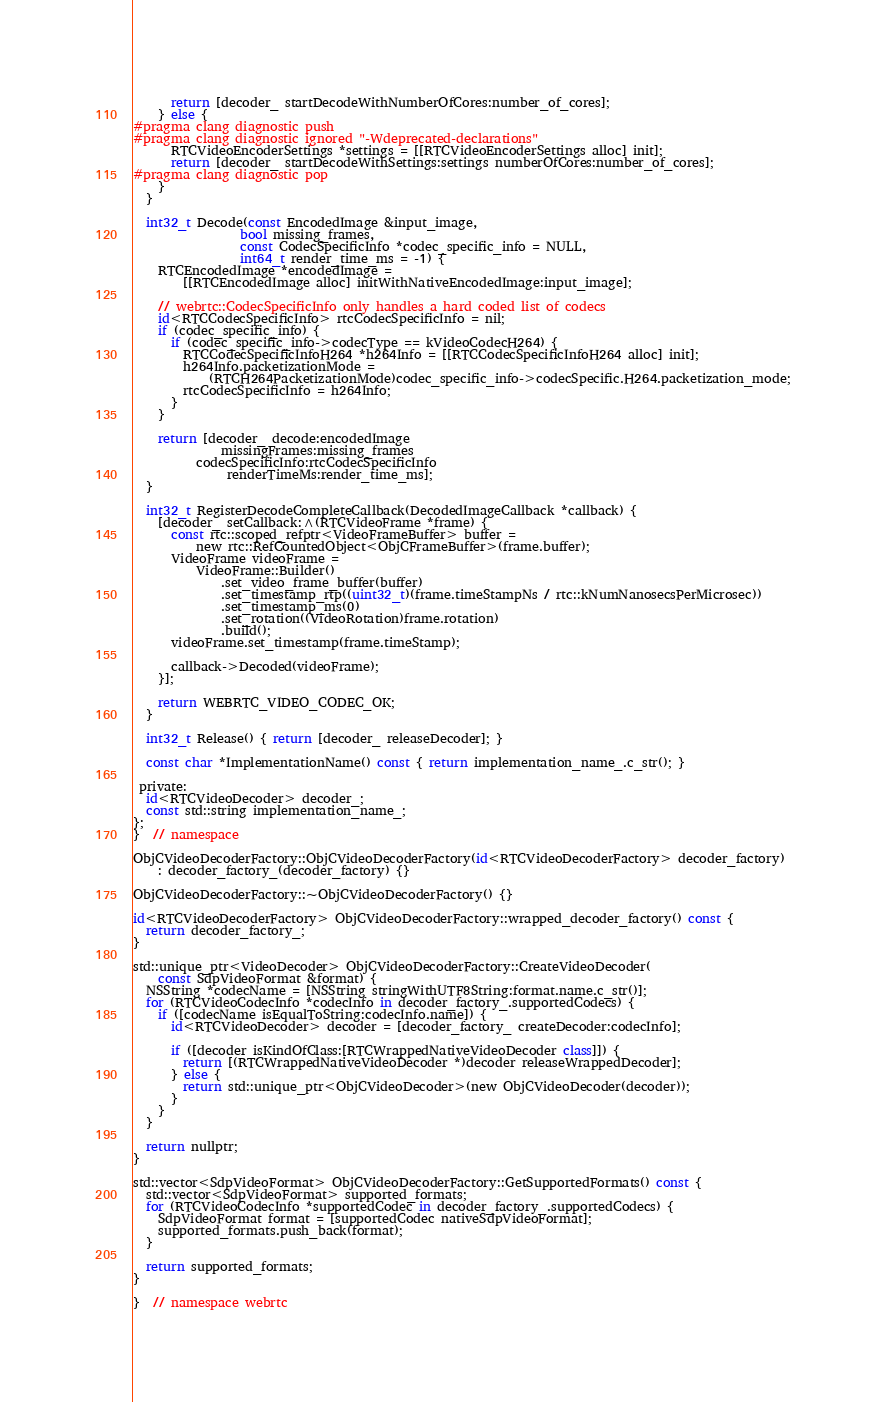<code> <loc_0><loc_0><loc_500><loc_500><_ObjectiveC_>      return [decoder_ startDecodeWithNumberOfCores:number_of_cores];
    } else {
#pragma clang diagnostic push
#pragma clang diagnostic ignored "-Wdeprecated-declarations"
      RTCVideoEncoderSettings *settings = [[RTCVideoEncoderSettings alloc] init];
      return [decoder_ startDecodeWithSettings:settings numberOfCores:number_of_cores];
#pragma clang diagnostic pop
    }
  }

  int32_t Decode(const EncodedImage &input_image,
                 bool missing_frames,
                 const CodecSpecificInfo *codec_specific_info = NULL,
                 int64_t render_time_ms = -1) {
    RTCEncodedImage *encodedImage =
        [[RTCEncodedImage alloc] initWithNativeEncodedImage:input_image];

    // webrtc::CodecSpecificInfo only handles a hard coded list of codecs
    id<RTCCodecSpecificInfo> rtcCodecSpecificInfo = nil;
    if (codec_specific_info) {
      if (codec_specific_info->codecType == kVideoCodecH264) {
        RTCCodecSpecificInfoH264 *h264Info = [[RTCCodecSpecificInfoH264 alloc] init];
        h264Info.packetizationMode =
            (RTCH264PacketizationMode)codec_specific_info->codecSpecific.H264.packetization_mode;
        rtcCodecSpecificInfo = h264Info;
      }
    }

    return [decoder_ decode:encodedImage
              missingFrames:missing_frames
          codecSpecificInfo:rtcCodecSpecificInfo
               renderTimeMs:render_time_ms];
  }

  int32_t RegisterDecodeCompleteCallback(DecodedImageCallback *callback) {
    [decoder_ setCallback:^(RTCVideoFrame *frame) {
      const rtc::scoped_refptr<VideoFrameBuffer> buffer =
          new rtc::RefCountedObject<ObjCFrameBuffer>(frame.buffer);
      VideoFrame videoFrame =
          VideoFrame::Builder()
              .set_video_frame_buffer(buffer)
              .set_timestamp_rtp((uint32_t)(frame.timeStampNs / rtc::kNumNanosecsPerMicrosec))
              .set_timestamp_ms(0)
              .set_rotation((VideoRotation)frame.rotation)
              .build();
      videoFrame.set_timestamp(frame.timeStamp);

      callback->Decoded(videoFrame);
    }];

    return WEBRTC_VIDEO_CODEC_OK;
  }

  int32_t Release() { return [decoder_ releaseDecoder]; }

  const char *ImplementationName() const { return implementation_name_.c_str(); }

 private:
  id<RTCVideoDecoder> decoder_;
  const std::string implementation_name_;
};
}  // namespace

ObjCVideoDecoderFactory::ObjCVideoDecoderFactory(id<RTCVideoDecoderFactory> decoder_factory)
    : decoder_factory_(decoder_factory) {}

ObjCVideoDecoderFactory::~ObjCVideoDecoderFactory() {}

id<RTCVideoDecoderFactory> ObjCVideoDecoderFactory::wrapped_decoder_factory() const {
  return decoder_factory_;
}

std::unique_ptr<VideoDecoder> ObjCVideoDecoderFactory::CreateVideoDecoder(
    const SdpVideoFormat &format) {
  NSString *codecName = [NSString stringWithUTF8String:format.name.c_str()];
  for (RTCVideoCodecInfo *codecInfo in decoder_factory_.supportedCodecs) {
    if ([codecName isEqualToString:codecInfo.name]) {
      id<RTCVideoDecoder> decoder = [decoder_factory_ createDecoder:codecInfo];

      if ([decoder isKindOfClass:[RTCWrappedNativeVideoDecoder class]]) {
        return [(RTCWrappedNativeVideoDecoder *)decoder releaseWrappedDecoder];
      } else {
        return std::unique_ptr<ObjCVideoDecoder>(new ObjCVideoDecoder(decoder));
      }
    }
  }

  return nullptr;
}

std::vector<SdpVideoFormat> ObjCVideoDecoderFactory::GetSupportedFormats() const {
  std::vector<SdpVideoFormat> supported_formats;
  for (RTCVideoCodecInfo *supportedCodec in decoder_factory_.supportedCodecs) {
    SdpVideoFormat format = [supportedCodec nativeSdpVideoFormat];
    supported_formats.push_back(format);
  }

  return supported_formats;
}

}  // namespace webrtc
</code> 